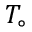<formula> <loc_0><loc_0><loc_500><loc_500>T _ { \circ }</formula> 